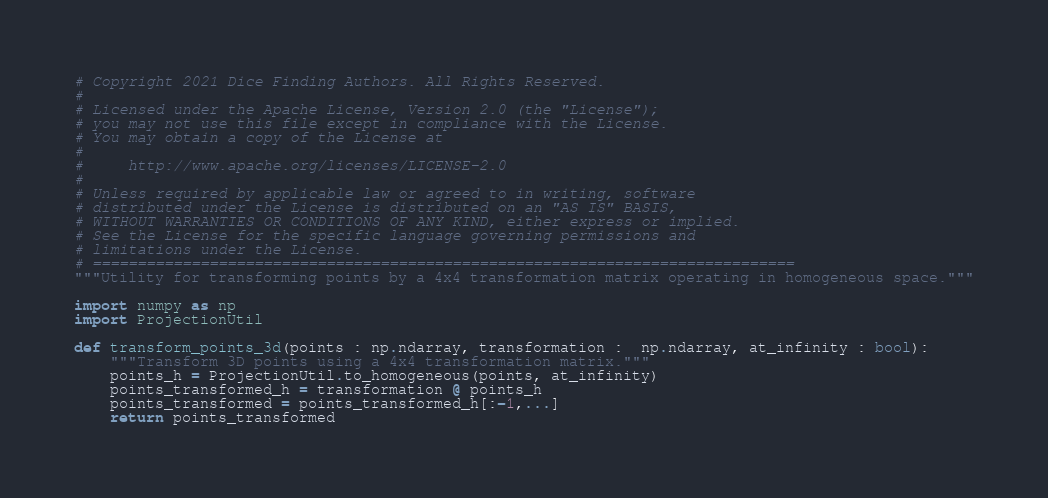<code> <loc_0><loc_0><loc_500><loc_500><_Python_># Copyright 2021 Dice Finding Authors. All Rights Reserved.
#
# Licensed under the Apache License, Version 2.0 (the "License");
# you may not use this file except in compliance with the License.
# You may obtain a copy of the License at
#
#     http://www.apache.org/licenses/LICENSE-2.0
#
# Unless required by applicable law or agreed to in writing, software
# distributed under the License is distributed on an "AS IS" BASIS,
# WITHOUT WARRANTIES OR CONDITIONS OF ANY KIND, either express or implied.
# See the License for the specific language governing permissions and
# limitations under the License.
# ==============================================================================
"""Utility for transforming points by a 4x4 transformation matrix operating in homogeneous space."""

import numpy as np
import ProjectionUtil

def transform_points_3d(points : np.ndarray, transformation :  np.ndarray, at_infinity : bool):
    """Transform 3D points using a 4x4 transformation matrix."""
    points_h = ProjectionUtil.to_homogeneous(points, at_infinity)
    points_transformed_h = transformation @ points_h
    points_transformed = points_transformed_h[:-1,...]
    return points_transformed</code> 